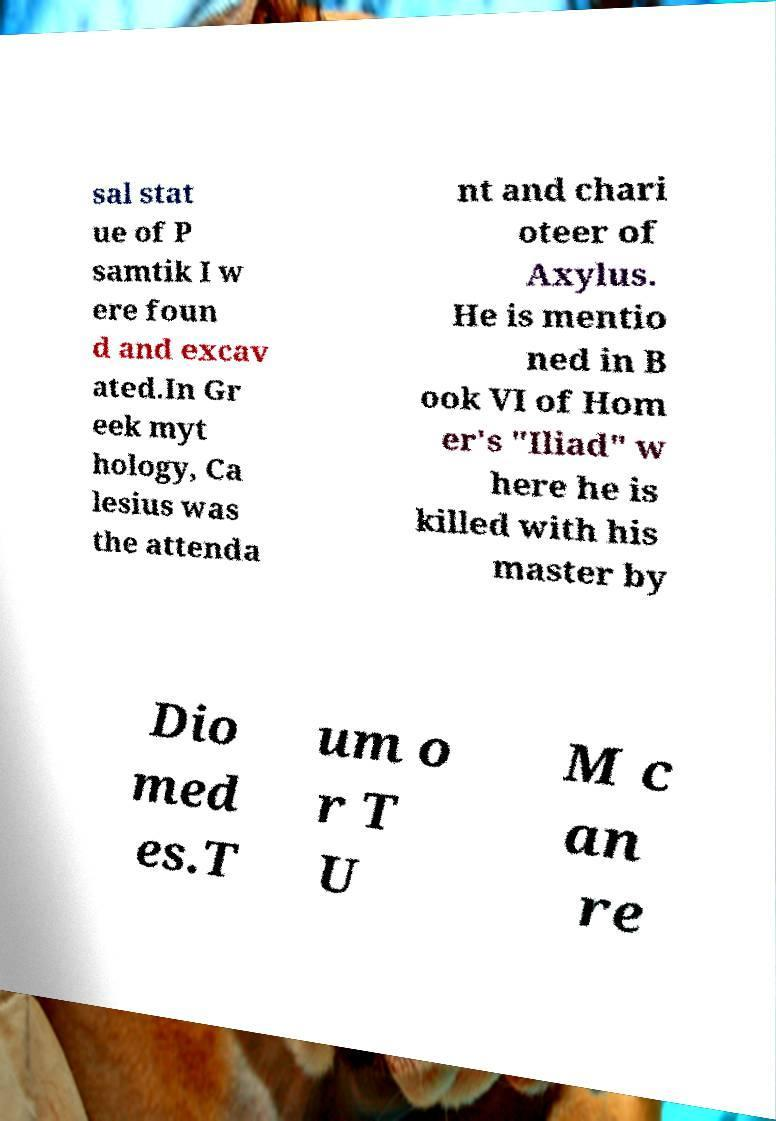Could you assist in decoding the text presented in this image and type it out clearly? sal stat ue of P samtik I w ere foun d and excav ated.In Gr eek myt hology, Ca lesius was the attenda nt and chari oteer of Axylus. He is mentio ned in B ook VI of Hom er's "Iliad" w here he is killed with his master by Dio med es.T um o r T U M c an re 